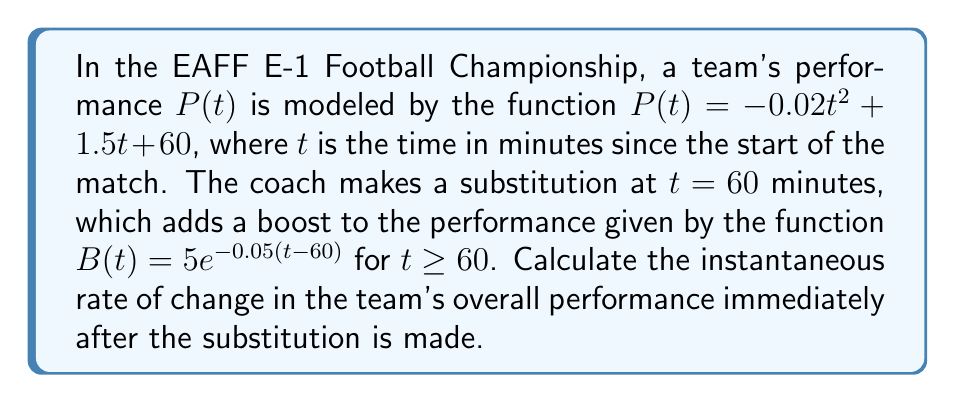Show me your answer to this math problem. To solve this problem, we need to follow these steps:

1) The overall performance function after the substitution is the sum of P(t) and B(t):
   $F(t) = P(t) + B(t) = -0.02t^2 + 1.5t + 60 + 5e^{-0.05(t-60)}$ for $t \geq 60$

2) To find the instantaneous rate of change, we need to calculate the derivative of F(t) and evaluate it at t = 60:

   $F'(t) = \frac{d}{dt}(-0.02t^2 + 1.5t + 60 + 5e^{-0.05(t-60)})$

3) Using the power rule and chain rule:
   $F'(t) = -0.04t + 1.5 + 5(-0.05)e^{-0.05(t-60)}$

4) Simplify:
   $F'(t) = -0.04t + 1.5 - 0.25e^{-0.05(t-60)}$

5) Evaluate at t = 60:
   $F'(60) = -0.04(60) + 1.5 - 0.25e^{-0.05(60-60)}$
   $= -2.4 + 1.5 - 0.25$
   $= -1.15$

The negative value indicates that the team's performance is decreasing at this instant, despite the substitution boost.
Answer: $-1.15$ performance units per minute 